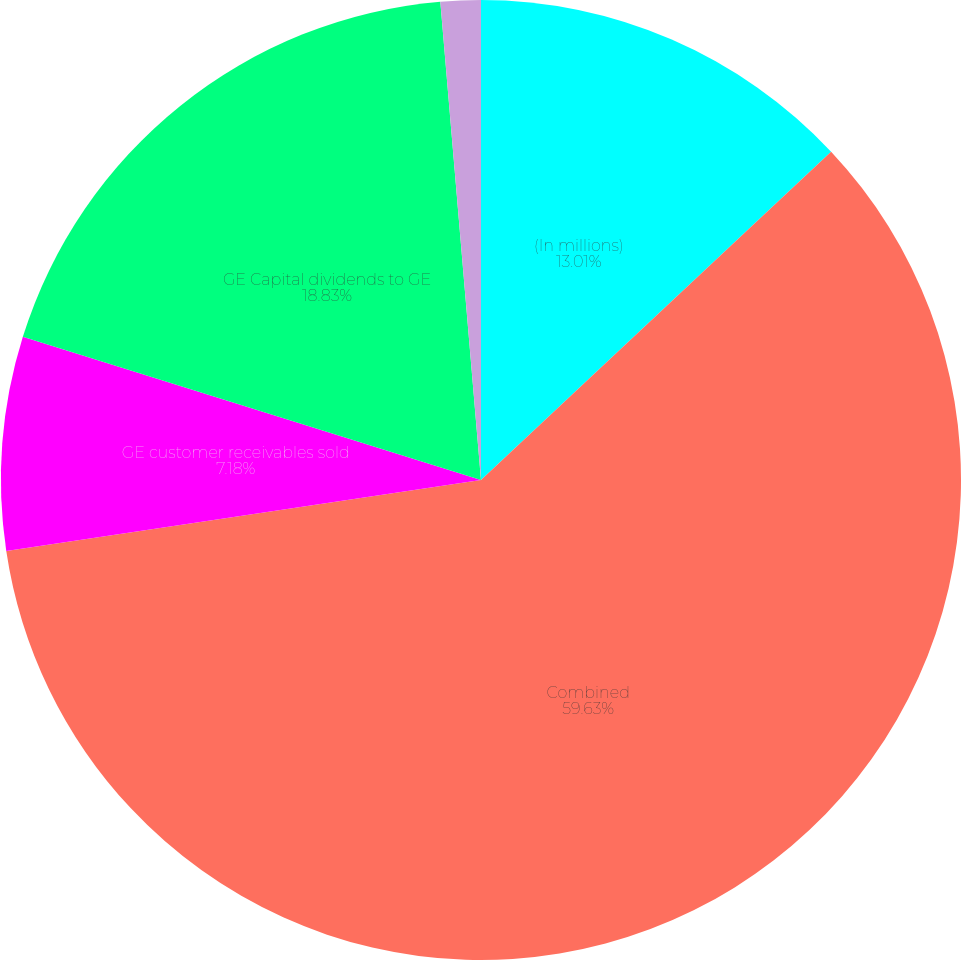<chart> <loc_0><loc_0><loc_500><loc_500><pie_chart><fcel>(In millions)<fcel>Combined<fcel>GE customer receivables sold<fcel>GE Capital dividends to GE<fcel>Other reclassifications and<nl><fcel>13.01%<fcel>59.63%<fcel>7.18%<fcel>18.83%<fcel>1.35%<nl></chart> 